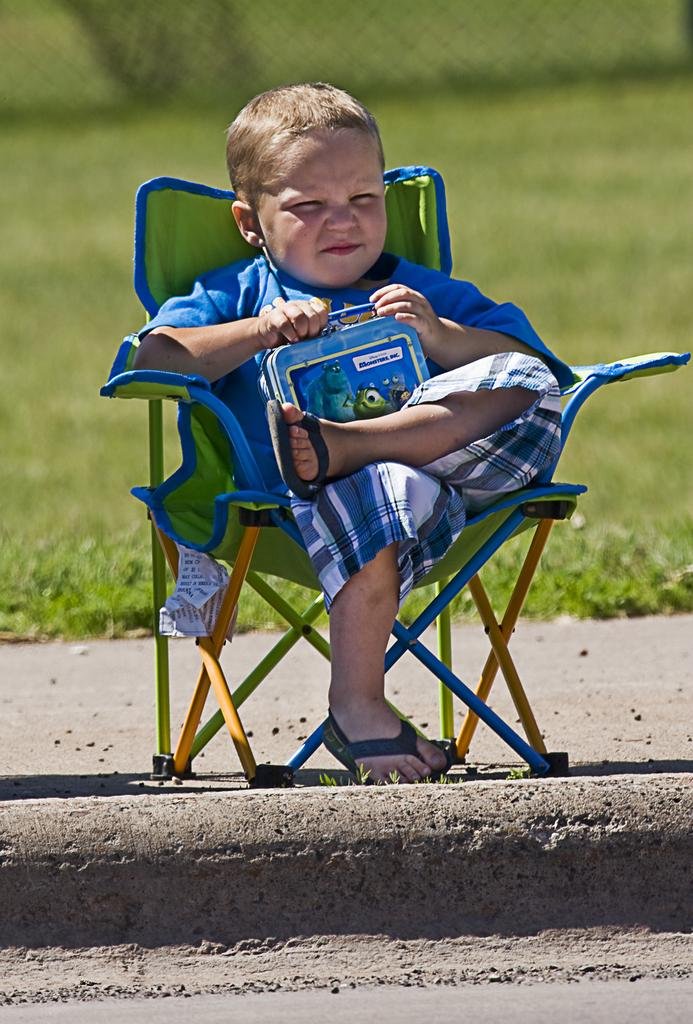Who is the main subject in the image? There is a boy in the image. What is the boy doing in the image? The boy is sitting on a chair in the image. What is the boy holding in the image? The boy is holding a box in the image. What type of natural environment is visible in the image? There is grass visible in the image. Where is the boy's grandmother in the image? There is no grandmother present in the image. What type of fire can be seen in the image? There is no fire present in the image. 